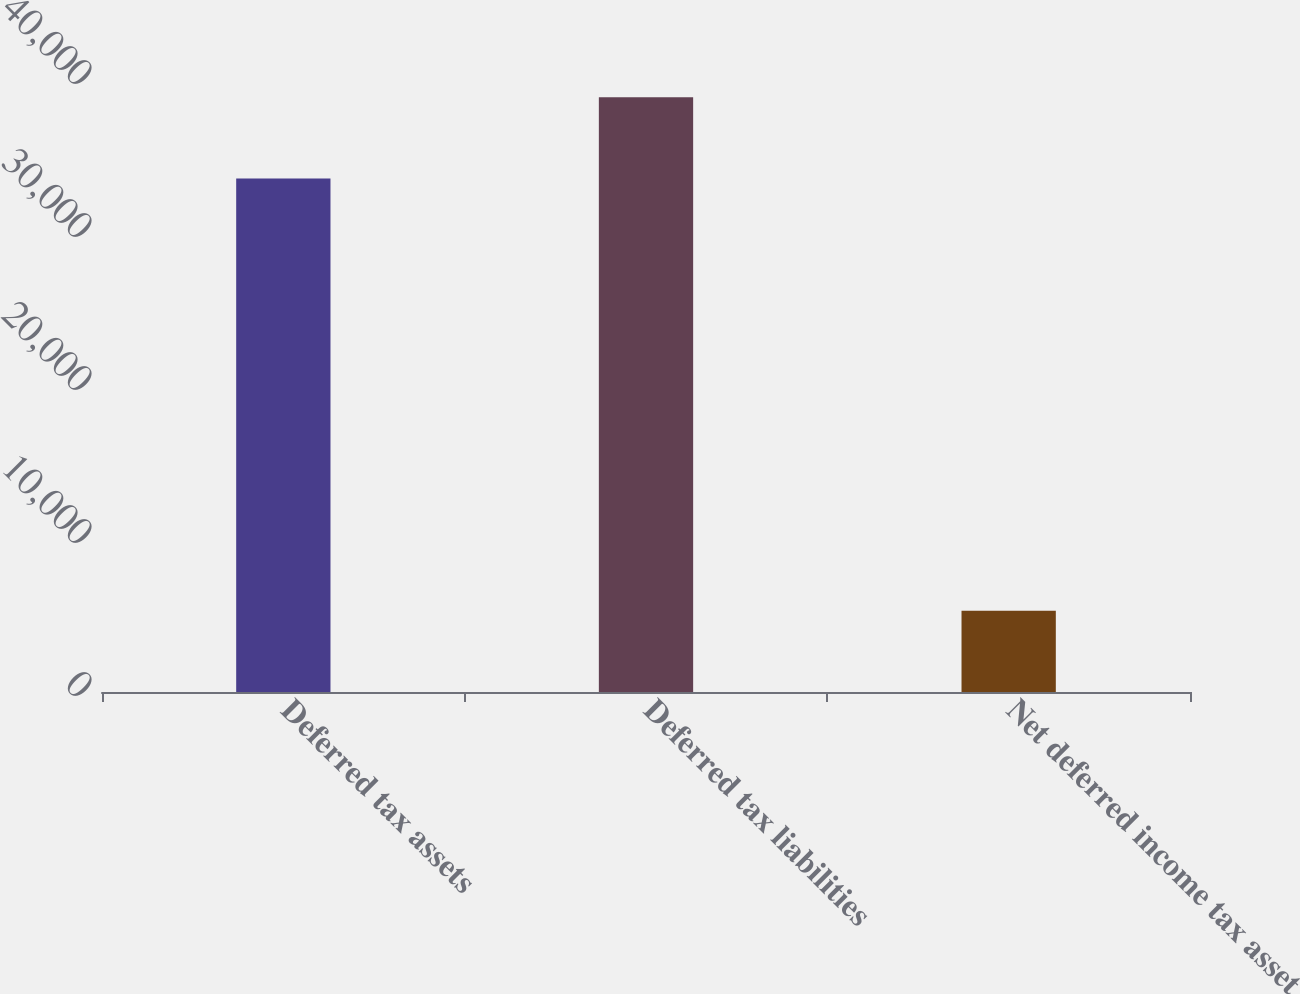Convert chart to OTSL. <chart><loc_0><loc_0><loc_500><loc_500><bar_chart><fcel>Deferred tax assets<fcel>Deferred tax liabilities<fcel>Net deferred income tax asset<nl><fcel>33564<fcel>38873<fcel>5309<nl></chart> 